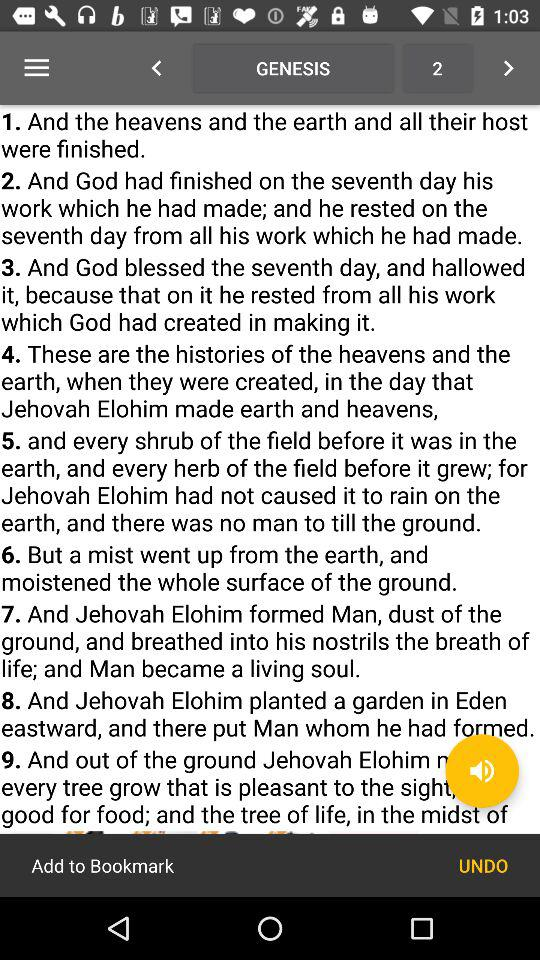When did God rest? God rested on the seventh day. 